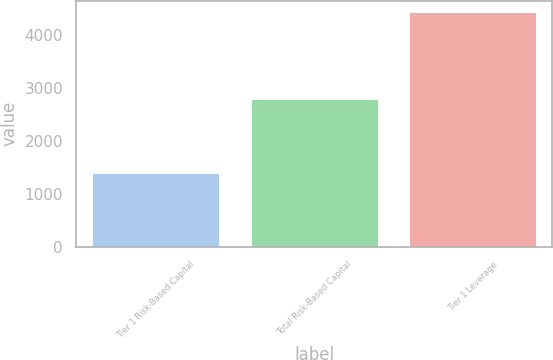Convert chart. <chart><loc_0><loc_0><loc_500><loc_500><bar_chart><fcel>Tier 1 Risk-Based Capital<fcel>Total Risk-Based Capital<fcel>Tier 1 Leverage<nl><fcel>1397<fcel>2793<fcel>4438<nl></chart> 